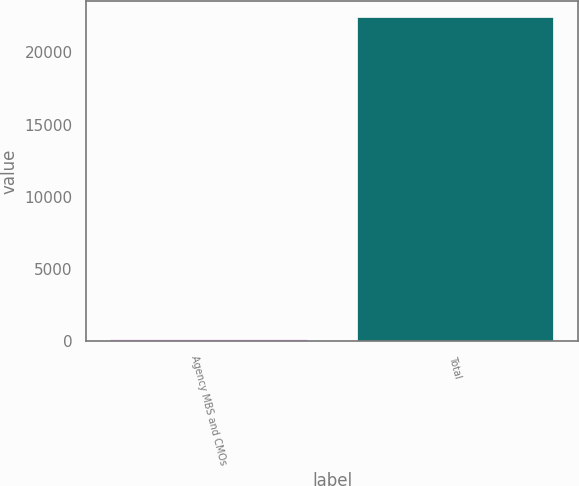Convert chart to OTSL. <chart><loc_0><loc_0><loc_500><loc_500><bar_chart><fcel>Agency MBS and CMOs<fcel>Total<nl><fcel>193<fcel>22409<nl></chart> 